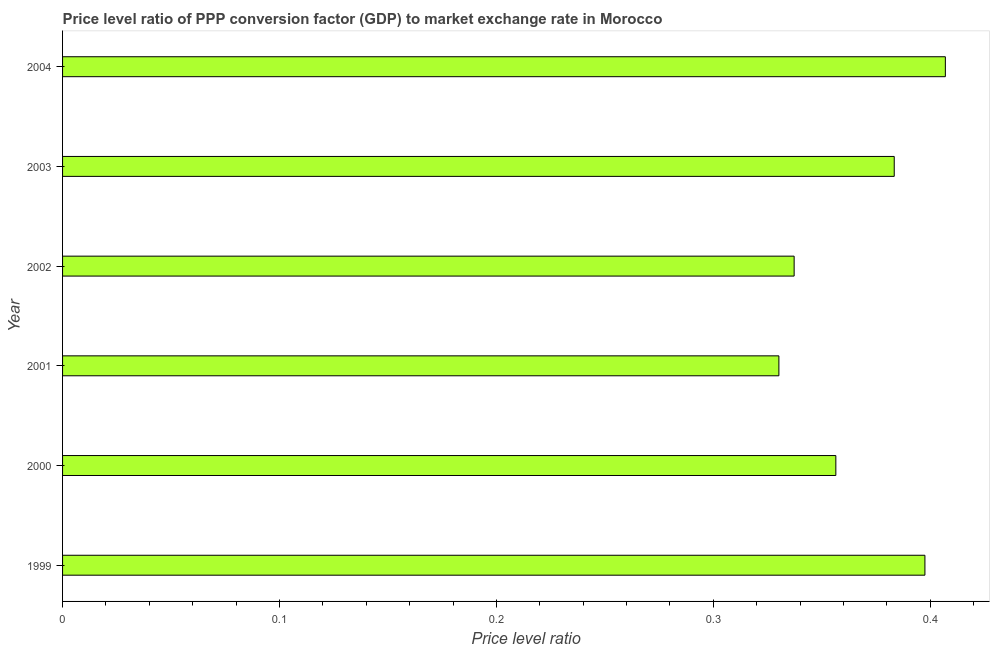Does the graph contain any zero values?
Ensure brevity in your answer.  No. Does the graph contain grids?
Keep it short and to the point. No. What is the title of the graph?
Make the answer very short. Price level ratio of PPP conversion factor (GDP) to market exchange rate in Morocco. What is the label or title of the X-axis?
Give a very brief answer. Price level ratio. What is the label or title of the Y-axis?
Ensure brevity in your answer.  Year. What is the price level ratio in 2003?
Your answer should be very brief. 0.38. Across all years, what is the maximum price level ratio?
Provide a succinct answer. 0.41. Across all years, what is the minimum price level ratio?
Ensure brevity in your answer.  0.33. In which year was the price level ratio minimum?
Your answer should be compact. 2001. What is the sum of the price level ratio?
Give a very brief answer. 2.21. What is the difference between the price level ratio in 1999 and 2003?
Offer a very short reply. 0.01. What is the average price level ratio per year?
Your answer should be very brief. 0.37. What is the median price level ratio?
Keep it short and to the point. 0.37. Do a majority of the years between 2002 and 2003 (inclusive) have price level ratio greater than 0.28 ?
Offer a very short reply. Yes. What is the ratio of the price level ratio in 2003 to that in 2004?
Offer a terse response. 0.94. Is the price level ratio in 2000 less than that in 2001?
Your answer should be very brief. No. Is the difference between the price level ratio in 2001 and 2003 greater than the difference between any two years?
Give a very brief answer. No. What is the difference between the highest and the second highest price level ratio?
Ensure brevity in your answer.  0.01. Is the sum of the price level ratio in 2000 and 2004 greater than the maximum price level ratio across all years?
Give a very brief answer. Yes. What is the difference between the highest and the lowest price level ratio?
Make the answer very short. 0.08. In how many years, is the price level ratio greater than the average price level ratio taken over all years?
Make the answer very short. 3. Are all the bars in the graph horizontal?
Ensure brevity in your answer.  Yes. Are the values on the major ticks of X-axis written in scientific E-notation?
Offer a terse response. No. What is the Price level ratio of 1999?
Make the answer very short. 0.4. What is the Price level ratio of 2000?
Offer a very short reply. 0.36. What is the Price level ratio in 2001?
Provide a short and direct response. 0.33. What is the Price level ratio in 2002?
Offer a terse response. 0.34. What is the Price level ratio in 2003?
Your answer should be compact. 0.38. What is the Price level ratio of 2004?
Keep it short and to the point. 0.41. What is the difference between the Price level ratio in 1999 and 2000?
Give a very brief answer. 0.04. What is the difference between the Price level ratio in 1999 and 2001?
Your answer should be compact. 0.07. What is the difference between the Price level ratio in 1999 and 2002?
Your answer should be very brief. 0.06. What is the difference between the Price level ratio in 1999 and 2003?
Make the answer very short. 0.01. What is the difference between the Price level ratio in 1999 and 2004?
Your answer should be very brief. -0.01. What is the difference between the Price level ratio in 2000 and 2001?
Keep it short and to the point. 0.03. What is the difference between the Price level ratio in 2000 and 2002?
Your answer should be very brief. 0.02. What is the difference between the Price level ratio in 2000 and 2003?
Keep it short and to the point. -0.03. What is the difference between the Price level ratio in 2000 and 2004?
Provide a short and direct response. -0.05. What is the difference between the Price level ratio in 2001 and 2002?
Your answer should be compact. -0.01. What is the difference between the Price level ratio in 2001 and 2003?
Give a very brief answer. -0.05. What is the difference between the Price level ratio in 2001 and 2004?
Keep it short and to the point. -0.08. What is the difference between the Price level ratio in 2002 and 2003?
Give a very brief answer. -0.05. What is the difference between the Price level ratio in 2002 and 2004?
Your answer should be very brief. -0.07. What is the difference between the Price level ratio in 2003 and 2004?
Provide a short and direct response. -0.02. What is the ratio of the Price level ratio in 1999 to that in 2000?
Keep it short and to the point. 1.11. What is the ratio of the Price level ratio in 1999 to that in 2001?
Ensure brevity in your answer.  1.2. What is the ratio of the Price level ratio in 1999 to that in 2002?
Your answer should be very brief. 1.18. What is the ratio of the Price level ratio in 1999 to that in 2003?
Provide a succinct answer. 1.04. What is the ratio of the Price level ratio in 1999 to that in 2004?
Offer a very short reply. 0.98. What is the ratio of the Price level ratio in 2000 to that in 2001?
Provide a short and direct response. 1.08. What is the ratio of the Price level ratio in 2000 to that in 2002?
Provide a short and direct response. 1.06. What is the ratio of the Price level ratio in 2000 to that in 2004?
Keep it short and to the point. 0.88. What is the ratio of the Price level ratio in 2001 to that in 2002?
Ensure brevity in your answer.  0.98. What is the ratio of the Price level ratio in 2001 to that in 2003?
Provide a succinct answer. 0.86. What is the ratio of the Price level ratio in 2001 to that in 2004?
Ensure brevity in your answer.  0.81. What is the ratio of the Price level ratio in 2002 to that in 2004?
Offer a terse response. 0.83. What is the ratio of the Price level ratio in 2003 to that in 2004?
Keep it short and to the point. 0.94. 